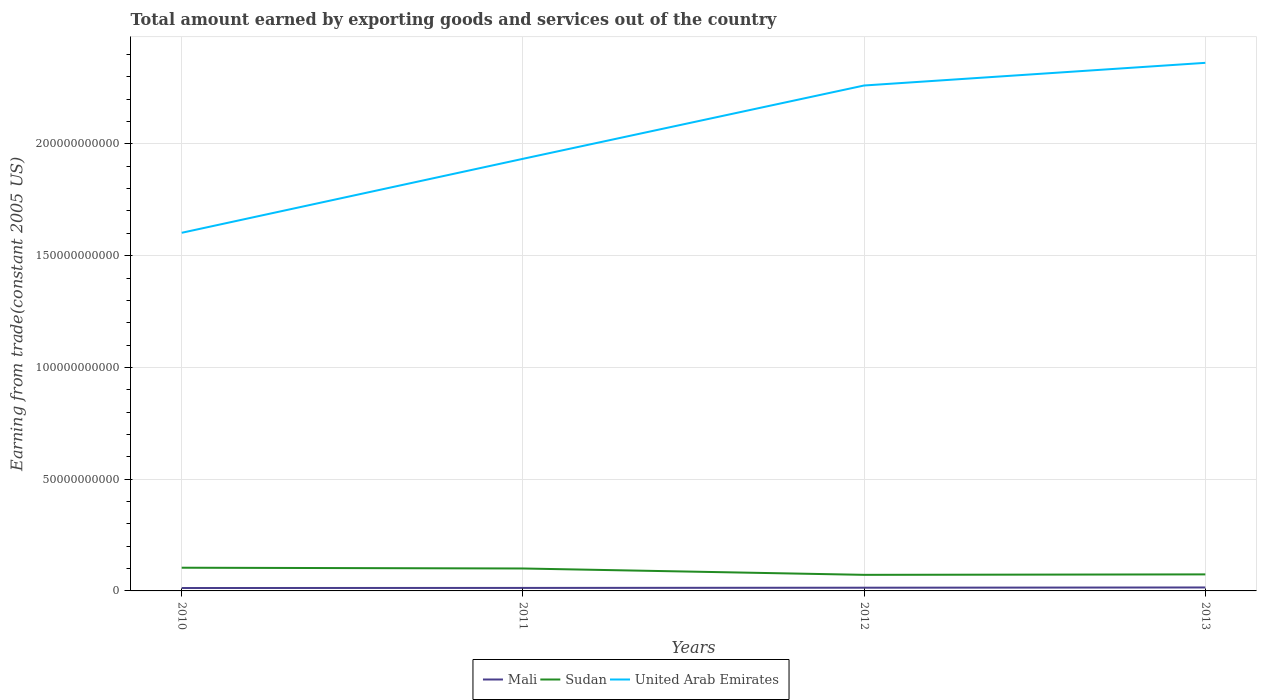How many different coloured lines are there?
Keep it short and to the point. 3. Is the number of lines equal to the number of legend labels?
Make the answer very short. Yes. Across all years, what is the maximum total amount earned by exporting goods and services in Mali?
Offer a terse response. 1.30e+09. In which year was the total amount earned by exporting goods and services in Mali maximum?
Offer a terse response. 2010. What is the total total amount earned by exporting goods and services in Sudan in the graph?
Provide a succinct answer. 3.43e+08. What is the difference between the highest and the second highest total amount earned by exporting goods and services in United Arab Emirates?
Offer a terse response. 7.60e+1. How many years are there in the graph?
Provide a short and direct response. 4. Are the values on the major ticks of Y-axis written in scientific E-notation?
Provide a short and direct response. No. Where does the legend appear in the graph?
Offer a terse response. Bottom center. How many legend labels are there?
Provide a short and direct response. 3. What is the title of the graph?
Your response must be concise. Total amount earned by exporting goods and services out of the country. What is the label or title of the Y-axis?
Provide a succinct answer. Earning from trade(constant 2005 US). What is the Earning from trade(constant 2005 US) in Mali in 2010?
Make the answer very short. 1.30e+09. What is the Earning from trade(constant 2005 US) of Sudan in 2010?
Your answer should be compact. 1.04e+1. What is the Earning from trade(constant 2005 US) of United Arab Emirates in 2010?
Make the answer very short. 1.60e+11. What is the Earning from trade(constant 2005 US) of Mali in 2011?
Ensure brevity in your answer.  1.34e+09. What is the Earning from trade(constant 2005 US) of Sudan in 2011?
Give a very brief answer. 1.00e+1. What is the Earning from trade(constant 2005 US) in United Arab Emirates in 2011?
Offer a very short reply. 1.93e+11. What is the Earning from trade(constant 2005 US) of Mali in 2012?
Your response must be concise. 1.44e+09. What is the Earning from trade(constant 2005 US) in Sudan in 2012?
Provide a short and direct response. 7.19e+09. What is the Earning from trade(constant 2005 US) in United Arab Emirates in 2012?
Give a very brief answer. 2.26e+11. What is the Earning from trade(constant 2005 US) in Mali in 2013?
Provide a short and direct response. 1.55e+09. What is the Earning from trade(constant 2005 US) in Sudan in 2013?
Make the answer very short. 7.40e+09. What is the Earning from trade(constant 2005 US) of United Arab Emirates in 2013?
Offer a terse response. 2.36e+11. Across all years, what is the maximum Earning from trade(constant 2005 US) in Mali?
Provide a succinct answer. 1.55e+09. Across all years, what is the maximum Earning from trade(constant 2005 US) in Sudan?
Ensure brevity in your answer.  1.04e+1. Across all years, what is the maximum Earning from trade(constant 2005 US) in United Arab Emirates?
Ensure brevity in your answer.  2.36e+11. Across all years, what is the minimum Earning from trade(constant 2005 US) of Mali?
Keep it short and to the point. 1.30e+09. Across all years, what is the minimum Earning from trade(constant 2005 US) in Sudan?
Your answer should be very brief. 7.19e+09. Across all years, what is the minimum Earning from trade(constant 2005 US) of United Arab Emirates?
Give a very brief answer. 1.60e+11. What is the total Earning from trade(constant 2005 US) in Mali in the graph?
Your response must be concise. 5.63e+09. What is the total Earning from trade(constant 2005 US) of Sudan in the graph?
Your answer should be compact. 3.50e+1. What is the total Earning from trade(constant 2005 US) of United Arab Emirates in the graph?
Provide a short and direct response. 8.16e+11. What is the difference between the Earning from trade(constant 2005 US) in Mali in 2010 and that in 2011?
Make the answer very short. -4.17e+07. What is the difference between the Earning from trade(constant 2005 US) in Sudan in 2010 and that in 2011?
Your answer should be compact. 3.43e+08. What is the difference between the Earning from trade(constant 2005 US) of United Arab Emirates in 2010 and that in 2011?
Offer a terse response. -3.31e+1. What is the difference between the Earning from trade(constant 2005 US) of Mali in 2010 and that in 2012?
Offer a terse response. -1.36e+08. What is the difference between the Earning from trade(constant 2005 US) of Sudan in 2010 and that in 2012?
Provide a succinct answer. 3.19e+09. What is the difference between the Earning from trade(constant 2005 US) of United Arab Emirates in 2010 and that in 2012?
Offer a terse response. -6.59e+1. What is the difference between the Earning from trade(constant 2005 US) of Mali in 2010 and that in 2013?
Your answer should be very brief. -2.44e+08. What is the difference between the Earning from trade(constant 2005 US) in Sudan in 2010 and that in 2013?
Your answer should be very brief. 2.99e+09. What is the difference between the Earning from trade(constant 2005 US) in United Arab Emirates in 2010 and that in 2013?
Ensure brevity in your answer.  -7.60e+1. What is the difference between the Earning from trade(constant 2005 US) in Mali in 2011 and that in 2012?
Your response must be concise. -9.41e+07. What is the difference between the Earning from trade(constant 2005 US) of Sudan in 2011 and that in 2012?
Make the answer very short. 2.85e+09. What is the difference between the Earning from trade(constant 2005 US) in United Arab Emirates in 2011 and that in 2012?
Your answer should be very brief. -3.28e+1. What is the difference between the Earning from trade(constant 2005 US) in Mali in 2011 and that in 2013?
Ensure brevity in your answer.  -2.02e+08. What is the difference between the Earning from trade(constant 2005 US) of Sudan in 2011 and that in 2013?
Give a very brief answer. 2.64e+09. What is the difference between the Earning from trade(constant 2005 US) in United Arab Emirates in 2011 and that in 2013?
Offer a terse response. -4.29e+1. What is the difference between the Earning from trade(constant 2005 US) of Mali in 2012 and that in 2013?
Give a very brief answer. -1.08e+08. What is the difference between the Earning from trade(constant 2005 US) of Sudan in 2012 and that in 2013?
Your answer should be compact. -2.07e+08. What is the difference between the Earning from trade(constant 2005 US) in United Arab Emirates in 2012 and that in 2013?
Provide a succinct answer. -1.01e+1. What is the difference between the Earning from trade(constant 2005 US) in Mali in 2010 and the Earning from trade(constant 2005 US) in Sudan in 2011?
Offer a very short reply. -8.74e+09. What is the difference between the Earning from trade(constant 2005 US) in Mali in 2010 and the Earning from trade(constant 2005 US) in United Arab Emirates in 2011?
Ensure brevity in your answer.  -1.92e+11. What is the difference between the Earning from trade(constant 2005 US) of Sudan in 2010 and the Earning from trade(constant 2005 US) of United Arab Emirates in 2011?
Provide a succinct answer. -1.83e+11. What is the difference between the Earning from trade(constant 2005 US) of Mali in 2010 and the Earning from trade(constant 2005 US) of Sudan in 2012?
Your response must be concise. -5.89e+09. What is the difference between the Earning from trade(constant 2005 US) of Mali in 2010 and the Earning from trade(constant 2005 US) of United Arab Emirates in 2012?
Offer a terse response. -2.25e+11. What is the difference between the Earning from trade(constant 2005 US) in Sudan in 2010 and the Earning from trade(constant 2005 US) in United Arab Emirates in 2012?
Your answer should be compact. -2.16e+11. What is the difference between the Earning from trade(constant 2005 US) in Mali in 2010 and the Earning from trade(constant 2005 US) in Sudan in 2013?
Ensure brevity in your answer.  -6.10e+09. What is the difference between the Earning from trade(constant 2005 US) of Mali in 2010 and the Earning from trade(constant 2005 US) of United Arab Emirates in 2013?
Offer a terse response. -2.35e+11. What is the difference between the Earning from trade(constant 2005 US) in Sudan in 2010 and the Earning from trade(constant 2005 US) in United Arab Emirates in 2013?
Your answer should be compact. -2.26e+11. What is the difference between the Earning from trade(constant 2005 US) of Mali in 2011 and the Earning from trade(constant 2005 US) of Sudan in 2012?
Your response must be concise. -5.85e+09. What is the difference between the Earning from trade(constant 2005 US) in Mali in 2011 and the Earning from trade(constant 2005 US) in United Arab Emirates in 2012?
Keep it short and to the point. -2.25e+11. What is the difference between the Earning from trade(constant 2005 US) in Sudan in 2011 and the Earning from trade(constant 2005 US) in United Arab Emirates in 2012?
Provide a short and direct response. -2.16e+11. What is the difference between the Earning from trade(constant 2005 US) in Mali in 2011 and the Earning from trade(constant 2005 US) in Sudan in 2013?
Your answer should be very brief. -6.05e+09. What is the difference between the Earning from trade(constant 2005 US) in Mali in 2011 and the Earning from trade(constant 2005 US) in United Arab Emirates in 2013?
Keep it short and to the point. -2.35e+11. What is the difference between the Earning from trade(constant 2005 US) of Sudan in 2011 and the Earning from trade(constant 2005 US) of United Arab Emirates in 2013?
Your answer should be compact. -2.26e+11. What is the difference between the Earning from trade(constant 2005 US) of Mali in 2012 and the Earning from trade(constant 2005 US) of Sudan in 2013?
Make the answer very short. -5.96e+09. What is the difference between the Earning from trade(constant 2005 US) of Mali in 2012 and the Earning from trade(constant 2005 US) of United Arab Emirates in 2013?
Give a very brief answer. -2.35e+11. What is the difference between the Earning from trade(constant 2005 US) of Sudan in 2012 and the Earning from trade(constant 2005 US) of United Arab Emirates in 2013?
Ensure brevity in your answer.  -2.29e+11. What is the average Earning from trade(constant 2005 US) of Mali per year?
Offer a very short reply. 1.41e+09. What is the average Earning from trade(constant 2005 US) in Sudan per year?
Provide a succinct answer. 8.75e+09. What is the average Earning from trade(constant 2005 US) in United Arab Emirates per year?
Provide a succinct answer. 2.04e+11. In the year 2010, what is the difference between the Earning from trade(constant 2005 US) in Mali and Earning from trade(constant 2005 US) in Sudan?
Give a very brief answer. -9.08e+09. In the year 2010, what is the difference between the Earning from trade(constant 2005 US) in Mali and Earning from trade(constant 2005 US) in United Arab Emirates?
Provide a succinct answer. -1.59e+11. In the year 2010, what is the difference between the Earning from trade(constant 2005 US) of Sudan and Earning from trade(constant 2005 US) of United Arab Emirates?
Keep it short and to the point. -1.50e+11. In the year 2011, what is the difference between the Earning from trade(constant 2005 US) in Mali and Earning from trade(constant 2005 US) in Sudan?
Give a very brief answer. -8.70e+09. In the year 2011, what is the difference between the Earning from trade(constant 2005 US) of Mali and Earning from trade(constant 2005 US) of United Arab Emirates?
Your response must be concise. -1.92e+11. In the year 2011, what is the difference between the Earning from trade(constant 2005 US) in Sudan and Earning from trade(constant 2005 US) in United Arab Emirates?
Your answer should be very brief. -1.83e+11. In the year 2012, what is the difference between the Earning from trade(constant 2005 US) in Mali and Earning from trade(constant 2005 US) in Sudan?
Your answer should be compact. -5.75e+09. In the year 2012, what is the difference between the Earning from trade(constant 2005 US) of Mali and Earning from trade(constant 2005 US) of United Arab Emirates?
Provide a short and direct response. -2.25e+11. In the year 2012, what is the difference between the Earning from trade(constant 2005 US) of Sudan and Earning from trade(constant 2005 US) of United Arab Emirates?
Offer a very short reply. -2.19e+11. In the year 2013, what is the difference between the Earning from trade(constant 2005 US) of Mali and Earning from trade(constant 2005 US) of Sudan?
Your response must be concise. -5.85e+09. In the year 2013, what is the difference between the Earning from trade(constant 2005 US) in Mali and Earning from trade(constant 2005 US) in United Arab Emirates?
Give a very brief answer. -2.35e+11. In the year 2013, what is the difference between the Earning from trade(constant 2005 US) in Sudan and Earning from trade(constant 2005 US) in United Arab Emirates?
Keep it short and to the point. -2.29e+11. What is the ratio of the Earning from trade(constant 2005 US) of Sudan in 2010 to that in 2011?
Make the answer very short. 1.03. What is the ratio of the Earning from trade(constant 2005 US) of United Arab Emirates in 2010 to that in 2011?
Ensure brevity in your answer.  0.83. What is the ratio of the Earning from trade(constant 2005 US) in Mali in 2010 to that in 2012?
Keep it short and to the point. 0.91. What is the ratio of the Earning from trade(constant 2005 US) in Sudan in 2010 to that in 2012?
Provide a short and direct response. 1.44. What is the ratio of the Earning from trade(constant 2005 US) in United Arab Emirates in 2010 to that in 2012?
Ensure brevity in your answer.  0.71. What is the ratio of the Earning from trade(constant 2005 US) of Mali in 2010 to that in 2013?
Offer a very short reply. 0.84. What is the ratio of the Earning from trade(constant 2005 US) in Sudan in 2010 to that in 2013?
Ensure brevity in your answer.  1.4. What is the ratio of the Earning from trade(constant 2005 US) in United Arab Emirates in 2010 to that in 2013?
Your answer should be compact. 0.68. What is the ratio of the Earning from trade(constant 2005 US) in Mali in 2011 to that in 2012?
Ensure brevity in your answer.  0.93. What is the ratio of the Earning from trade(constant 2005 US) of Sudan in 2011 to that in 2012?
Make the answer very short. 1.4. What is the ratio of the Earning from trade(constant 2005 US) of United Arab Emirates in 2011 to that in 2012?
Your answer should be compact. 0.85. What is the ratio of the Earning from trade(constant 2005 US) in Mali in 2011 to that in 2013?
Keep it short and to the point. 0.87. What is the ratio of the Earning from trade(constant 2005 US) of Sudan in 2011 to that in 2013?
Keep it short and to the point. 1.36. What is the ratio of the Earning from trade(constant 2005 US) in United Arab Emirates in 2011 to that in 2013?
Your answer should be very brief. 0.82. What is the ratio of the Earning from trade(constant 2005 US) of Mali in 2012 to that in 2013?
Keep it short and to the point. 0.93. What is the ratio of the Earning from trade(constant 2005 US) in Sudan in 2012 to that in 2013?
Offer a terse response. 0.97. What is the ratio of the Earning from trade(constant 2005 US) of United Arab Emirates in 2012 to that in 2013?
Provide a succinct answer. 0.96. What is the difference between the highest and the second highest Earning from trade(constant 2005 US) of Mali?
Your response must be concise. 1.08e+08. What is the difference between the highest and the second highest Earning from trade(constant 2005 US) of Sudan?
Your response must be concise. 3.43e+08. What is the difference between the highest and the second highest Earning from trade(constant 2005 US) in United Arab Emirates?
Offer a terse response. 1.01e+1. What is the difference between the highest and the lowest Earning from trade(constant 2005 US) in Mali?
Keep it short and to the point. 2.44e+08. What is the difference between the highest and the lowest Earning from trade(constant 2005 US) of Sudan?
Ensure brevity in your answer.  3.19e+09. What is the difference between the highest and the lowest Earning from trade(constant 2005 US) in United Arab Emirates?
Your response must be concise. 7.60e+1. 